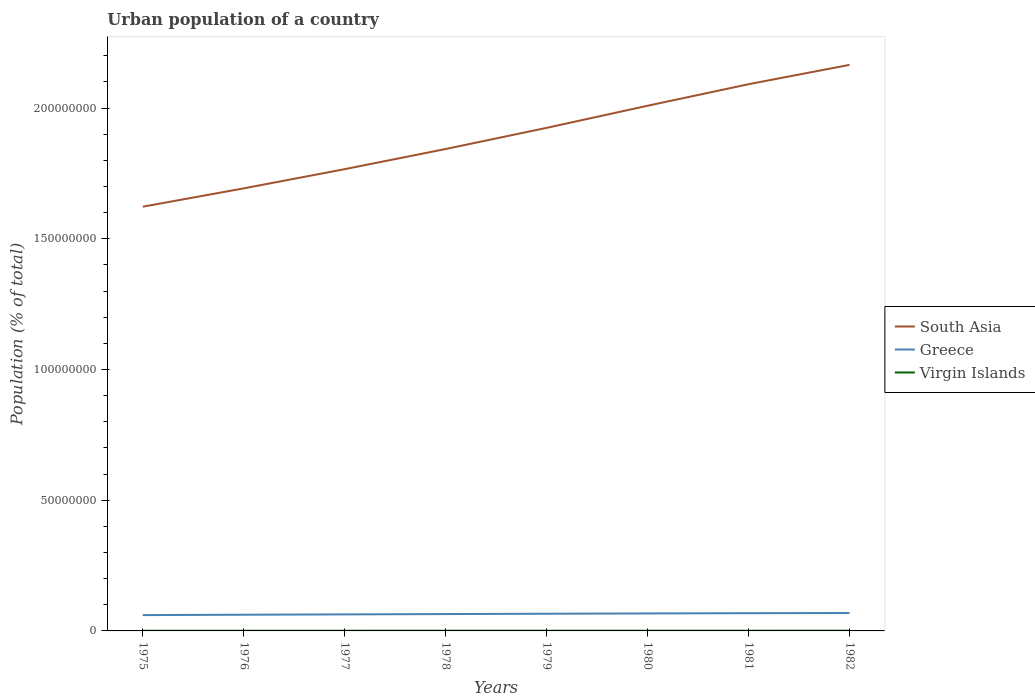Is the number of lines equal to the number of legend labels?
Your answer should be very brief. Yes. Across all years, what is the maximum urban population in South Asia?
Keep it short and to the point. 1.62e+08. In which year was the urban population in South Asia maximum?
Offer a very short reply. 1975. What is the total urban population in South Asia in the graph?
Offer a terse response. -3.99e+07. What is the difference between the highest and the second highest urban population in South Asia?
Offer a terse response. 5.42e+07. What is the difference between the highest and the lowest urban population in South Asia?
Give a very brief answer. 4. How many years are there in the graph?
Your response must be concise. 8. Are the values on the major ticks of Y-axis written in scientific E-notation?
Your answer should be compact. No. Does the graph contain grids?
Your answer should be compact. No. How are the legend labels stacked?
Offer a very short reply. Vertical. What is the title of the graph?
Keep it short and to the point. Urban population of a country. Does "Maldives" appear as one of the legend labels in the graph?
Your answer should be very brief. No. What is the label or title of the X-axis?
Offer a very short reply. Years. What is the label or title of the Y-axis?
Offer a terse response. Population (% of total). What is the Population (% of total) of South Asia in 1975?
Your answer should be very brief. 1.62e+08. What is the Population (% of total) in Greece in 1975?
Offer a very short reply. 6.06e+06. What is the Population (% of total) of Virgin Islands in 1975?
Your answer should be compact. 7.07e+04. What is the Population (% of total) of South Asia in 1976?
Make the answer very short. 1.69e+08. What is the Population (% of total) of Greece in 1976?
Your response must be concise. 6.20e+06. What is the Population (% of total) in Virgin Islands in 1976?
Offer a terse response. 7.32e+04. What is the Population (% of total) of South Asia in 1977?
Ensure brevity in your answer.  1.77e+08. What is the Population (% of total) in Greece in 1977?
Make the answer very short. 6.32e+06. What is the Population (% of total) in Virgin Islands in 1977?
Offer a terse response. 7.19e+04. What is the Population (% of total) of South Asia in 1978?
Your answer should be very brief. 1.84e+08. What is the Population (% of total) in Greece in 1978?
Give a very brief answer. 6.45e+06. What is the Population (% of total) in Virgin Islands in 1978?
Keep it short and to the point. 7.51e+04. What is the Population (% of total) in South Asia in 1979?
Provide a succinct answer. 1.92e+08. What is the Population (% of total) in Greece in 1979?
Your answer should be very brief. 6.58e+06. What is the Population (% of total) in Virgin Islands in 1979?
Offer a terse response. 7.61e+04. What is the Population (% of total) in South Asia in 1980?
Your response must be concise. 2.01e+08. What is the Population (% of total) of Greece in 1980?
Make the answer very short. 6.69e+06. What is the Population (% of total) in Virgin Islands in 1980?
Keep it short and to the point. 7.77e+04. What is the Population (% of total) in South Asia in 1981?
Provide a succinct answer. 2.09e+08. What is the Population (% of total) in Greece in 1981?
Offer a terse response. 6.79e+06. What is the Population (% of total) in Virgin Islands in 1981?
Give a very brief answer. 7.94e+04. What is the Population (% of total) in South Asia in 1982?
Your answer should be compact. 2.16e+08. What is the Population (% of total) of Greece in 1982?
Your response must be concise. 6.85e+06. What is the Population (% of total) in Virgin Islands in 1982?
Ensure brevity in your answer.  8.35e+04. Across all years, what is the maximum Population (% of total) of South Asia?
Your answer should be compact. 2.16e+08. Across all years, what is the maximum Population (% of total) in Greece?
Keep it short and to the point. 6.85e+06. Across all years, what is the maximum Population (% of total) of Virgin Islands?
Offer a very short reply. 8.35e+04. Across all years, what is the minimum Population (% of total) of South Asia?
Your response must be concise. 1.62e+08. Across all years, what is the minimum Population (% of total) of Greece?
Provide a succinct answer. 6.06e+06. Across all years, what is the minimum Population (% of total) in Virgin Islands?
Ensure brevity in your answer.  7.07e+04. What is the total Population (% of total) of South Asia in the graph?
Give a very brief answer. 1.51e+09. What is the total Population (% of total) in Greece in the graph?
Provide a succinct answer. 5.19e+07. What is the total Population (% of total) of Virgin Islands in the graph?
Keep it short and to the point. 6.08e+05. What is the difference between the Population (% of total) of South Asia in 1975 and that in 1976?
Your answer should be very brief. -7.01e+06. What is the difference between the Population (% of total) of Greece in 1975 and that in 1976?
Make the answer very short. -1.40e+05. What is the difference between the Population (% of total) in Virgin Islands in 1975 and that in 1976?
Ensure brevity in your answer.  -2506. What is the difference between the Population (% of total) in South Asia in 1975 and that in 1977?
Offer a very short reply. -1.44e+07. What is the difference between the Population (% of total) in Greece in 1975 and that in 1977?
Your answer should be very brief. -2.66e+05. What is the difference between the Population (% of total) in Virgin Islands in 1975 and that in 1977?
Ensure brevity in your answer.  -1157. What is the difference between the Population (% of total) in South Asia in 1975 and that in 1978?
Offer a very short reply. -2.21e+07. What is the difference between the Population (% of total) of Greece in 1975 and that in 1978?
Provide a short and direct response. -3.94e+05. What is the difference between the Population (% of total) in Virgin Islands in 1975 and that in 1978?
Your response must be concise. -4417. What is the difference between the Population (% of total) of South Asia in 1975 and that in 1979?
Offer a terse response. -3.02e+07. What is the difference between the Population (% of total) of Greece in 1975 and that in 1979?
Keep it short and to the point. -5.20e+05. What is the difference between the Population (% of total) in Virgin Islands in 1975 and that in 1979?
Make the answer very short. -5329. What is the difference between the Population (% of total) in South Asia in 1975 and that in 1980?
Your response must be concise. -3.86e+07. What is the difference between the Population (% of total) in Greece in 1975 and that in 1980?
Your answer should be very brief. -6.31e+05. What is the difference between the Population (% of total) in Virgin Islands in 1975 and that in 1980?
Ensure brevity in your answer.  -7013. What is the difference between the Population (% of total) in South Asia in 1975 and that in 1981?
Provide a succinct answer. -4.68e+07. What is the difference between the Population (% of total) in Greece in 1975 and that in 1981?
Your answer should be very brief. -7.30e+05. What is the difference between the Population (% of total) of Virgin Islands in 1975 and that in 1981?
Your answer should be very brief. -8683. What is the difference between the Population (% of total) in South Asia in 1975 and that in 1982?
Offer a very short reply. -5.42e+07. What is the difference between the Population (% of total) in Greece in 1975 and that in 1982?
Give a very brief answer. -7.91e+05. What is the difference between the Population (% of total) in Virgin Islands in 1975 and that in 1982?
Your answer should be very brief. -1.28e+04. What is the difference between the Population (% of total) in South Asia in 1976 and that in 1977?
Offer a very short reply. -7.35e+06. What is the difference between the Population (% of total) in Greece in 1976 and that in 1977?
Offer a very short reply. -1.26e+05. What is the difference between the Population (% of total) in Virgin Islands in 1976 and that in 1977?
Offer a very short reply. 1349. What is the difference between the Population (% of total) of South Asia in 1976 and that in 1978?
Provide a short and direct response. -1.51e+07. What is the difference between the Population (% of total) in Greece in 1976 and that in 1978?
Provide a succinct answer. -2.54e+05. What is the difference between the Population (% of total) of Virgin Islands in 1976 and that in 1978?
Provide a short and direct response. -1911. What is the difference between the Population (% of total) of South Asia in 1976 and that in 1979?
Provide a succinct answer. -2.31e+07. What is the difference between the Population (% of total) of Greece in 1976 and that in 1979?
Make the answer very short. -3.80e+05. What is the difference between the Population (% of total) in Virgin Islands in 1976 and that in 1979?
Provide a succinct answer. -2823. What is the difference between the Population (% of total) of South Asia in 1976 and that in 1980?
Offer a very short reply. -3.16e+07. What is the difference between the Population (% of total) in Greece in 1976 and that in 1980?
Keep it short and to the point. -4.91e+05. What is the difference between the Population (% of total) in Virgin Islands in 1976 and that in 1980?
Provide a succinct answer. -4507. What is the difference between the Population (% of total) in South Asia in 1976 and that in 1981?
Your answer should be very brief. -3.98e+07. What is the difference between the Population (% of total) of Greece in 1976 and that in 1981?
Provide a short and direct response. -5.90e+05. What is the difference between the Population (% of total) in Virgin Islands in 1976 and that in 1981?
Make the answer very short. -6177. What is the difference between the Population (% of total) in South Asia in 1976 and that in 1982?
Ensure brevity in your answer.  -4.72e+07. What is the difference between the Population (% of total) in Greece in 1976 and that in 1982?
Your response must be concise. -6.51e+05. What is the difference between the Population (% of total) in Virgin Islands in 1976 and that in 1982?
Your answer should be compact. -1.03e+04. What is the difference between the Population (% of total) in South Asia in 1977 and that in 1978?
Provide a succinct answer. -7.71e+06. What is the difference between the Population (% of total) of Greece in 1977 and that in 1978?
Provide a succinct answer. -1.28e+05. What is the difference between the Population (% of total) in Virgin Islands in 1977 and that in 1978?
Keep it short and to the point. -3260. What is the difference between the Population (% of total) of South Asia in 1977 and that in 1979?
Provide a succinct answer. -1.58e+07. What is the difference between the Population (% of total) in Greece in 1977 and that in 1979?
Provide a succinct answer. -2.54e+05. What is the difference between the Population (% of total) of Virgin Islands in 1977 and that in 1979?
Make the answer very short. -4172. What is the difference between the Population (% of total) in South Asia in 1977 and that in 1980?
Offer a terse response. -2.43e+07. What is the difference between the Population (% of total) in Greece in 1977 and that in 1980?
Offer a terse response. -3.65e+05. What is the difference between the Population (% of total) in Virgin Islands in 1977 and that in 1980?
Offer a terse response. -5856. What is the difference between the Population (% of total) of South Asia in 1977 and that in 1981?
Your answer should be very brief. -3.25e+07. What is the difference between the Population (% of total) in Greece in 1977 and that in 1981?
Your answer should be compact. -4.64e+05. What is the difference between the Population (% of total) of Virgin Islands in 1977 and that in 1981?
Your answer should be compact. -7526. What is the difference between the Population (% of total) of South Asia in 1977 and that in 1982?
Offer a very short reply. -3.99e+07. What is the difference between the Population (% of total) in Greece in 1977 and that in 1982?
Your answer should be compact. -5.25e+05. What is the difference between the Population (% of total) of Virgin Islands in 1977 and that in 1982?
Your answer should be very brief. -1.16e+04. What is the difference between the Population (% of total) of South Asia in 1978 and that in 1979?
Ensure brevity in your answer.  -8.09e+06. What is the difference between the Population (% of total) of Greece in 1978 and that in 1979?
Your answer should be compact. -1.26e+05. What is the difference between the Population (% of total) in Virgin Islands in 1978 and that in 1979?
Ensure brevity in your answer.  -912. What is the difference between the Population (% of total) of South Asia in 1978 and that in 1980?
Ensure brevity in your answer.  -1.65e+07. What is the difference between the Population (% of total) in Greece in 1978 and that in 1980?
Keep it short and to the point. -2.37e+05. What is the difference between the Population (% of total) in Virgin Islands in 1978 and that in 1980?
Provide a succinct answer. -2596. What is the difference between the Population (% of total) of South Asia in 1978 and that in 1981?
Your answer should be compact. -2.48e+07. What is the difference between the Population (% of total) in Greece in 1978 and that in 1981?
Provide a short and direct response. -3.36e+05. What is the difference between the Population (% of total) of Virgin Islands in 1978 and that in 1981?
Keep it short and to the point. -4266. What is the difference between the Population (% of total) of South Asia in 1978 and that in 1982?
Your answer should be compact. -3.22e+07. What is the difference between the Population (% of total) of Greece in 1978 and that in 1982?
Offer a terse response. -3.97e+05. What is the difference between the Population (% of total) of Virgin Islands in 1978 and that in 1982?
Offer a terse response. -8382. What is the difference between the Population (% of total) in South Asia in 1979 and that in 1980?
Keep it short and to the point. -8.46e+06. What is the difference between the Population (% of total) in Greece in 1979 and that in 1980?
Your answer should be very brief. -1.11e+05. What is the difference between the Population (% of total) of Virgin Islands in 1979 and that in 1980?
Offer a very short reply. -1684. What is the difference between the Population (% of total) of South Asia in 1979 and that in 1981?
Make the answer very short. -1.67e+07. What is the difference between the Population (% of total) of Greece in 1979 and that in 1981?
Offer a terse response. -2.10e+05. What is the difference between the Population (% of total) of Virgin Islands in 1979 and that in 1981?
Your answer should be very brief. -3354. What is the difference between the Population (% of total) of South Asia in 1979 and that in 1982?
Offer a terse response. -2.41e+07. What is the difference between the Population (% of total) of Greece in 1979 and that in 1982?
Provide a short and direct response. -2.71e+05. What is the difference between the Population (% of total) in Virgin Islands in 1979 and that in 1982?
Provide a short and direct response. -7470. What is the difference between the Population (% of total) of South Asia in 1980 and that in 1981?
Keep it short and to the point. -8.24e+06. What is the difference between the Population (% of total) of Greece in 1980 and that in 1981?
Make the answer very short. -9.94e+04. What is the difference between the Population (% of total) of Virgin Islands in 1980 and that in 1981?
Provide a succinct answer. -1670. What is the difference between the Population (% of total) of South Asia in 1980 and that in 1982?
Make the answer very short. -1.56e+07. What is the difference between the Population (% of total) of Greece in 1980 and that in 1982?
Offer a terse response. -1.60e+05. What is the difference between the Population (% of total) in Virgin Islands in 1980 and that in 1982?
Make the answer very short. -5786. What is the difference between the Population (% of total) in South Asia in 1981 and that in 1982?
Your response must be concise. -7.40e+06. What is the difference between the Population (% of total) in Greece in 1981 and that in 1982?
Your answer should be very brief. -6.10e+04. What is the difference between the Population (% of total) of Virgin Islands in 1981 and that in 1982?
Your answer should be compact. -4116. What is the difference between the Population (% of total) of South Asia in 1975 and the Population (% of total) of Greece in 1976?
Provide a short and direct response. 1.56e+08. What is the difference between the Population (% of total) of South Asia in 1975 and the Population (% of total) of Virgin Islands in 1976?
Give a very brief answer. 1.62e+08. What is the difference between the Population (% of total) in Greece in 1975 and the Population (% of total) in Virgin Islands in 1976?
Make the answer very short. 5.98e+06. What is the difference between the Population (% of total) in South Asia in 1975 and the Population (% of total) in Greece in 1977?
Keep it short and to the point. 1.56e+08. What is the difference between the Population (% of total) in South Asia in 1975 and the Population (% of total) in Virgin Islands in 1977?
Your response must be concise. 1.62e+08. What is the difference between the Population (% of total) in Greece in 1975 and the Population (% of total) in Virgin Islands in 1977?
Give a very brief answer. 5.98e+06. What is the difference between the Population (% of total) of South Asia in 1975 and the Population (% of total) of Greece in 1978?
Your answer should be compact. 1.56e+08. What is the difference between the Population (% of total) of South Asia in 1975 and the Population (% of total) of Virgin Islands in 1978?
Your answer should be very brief. 1.62e+08. What is the difference between the Population (% of total) of Greece in 1975 and the Population (% of total) of Virgin Islands in 1978?
Make the answer very short. 5.98e+06. What is the difference between the Population (% of total) in South Asia in 1975 and the Population (% of total) in Greece in 1979?
Provide a succinct answer. 1.56e+08. What is the difference between the Population (% of total) in South Asia in 1975 and the Population (% of total) in Virgin Islands in 1979?
Give a very brief answer. 1.62e+08. What is the difference between the Population (% of total) of Greece in 1975 and the Population (% of total) of Virgin Islands in 1979?
Make the answer very short. 5.98e+06. What is the difference between the Population (% of total) in South Asia in 1975 and the Population (% of total) in Greece in 1980?
Provide a short and direct response. 1.56e+08. What is the difference between the Population (% of total) in South Asia in 1975 and the Population (% of total) in Virgin Islands in 1980?
Your answer should be compact. 1.62e+08. What is the difference between the Population (% of total) of Greece in 1975 and the Population (% of total) of Virgin Islands in 1980?
Keep it short and to the point. 5.98e+06. What is the difference between the Population (% of total) in South Asia in 1975 and the Population (% of total) in Greece in 1981?
Give a very brief answer. 1.55e+08. What is the difference between the Population (% of total) in South Asia in 1975 and the Population (% of total) in Virgin Islands in 1981?
Make the answer very short. 1.62e+08. What is the difference between the Population (% of total) of Greece in 1975 and the Population (% of total) of Virgin Islands in 1981?
Give a very brief answer. 5.98e+06. What is the difference between the Population (% of total) of South Asia in 1975 and the Population (% of total) of Greece in 1982?
Offer a very short reply. 1.55e+08. What is the difference between the Population (% of total) in South Asia in 1975 and the Population (% of total) in Virgin Islands in 1982?
Give a very brief answer. 1.62e+08. What is the difference between the Population (% of total) in Greece in 1975 and the Population (% of total) in Virgin Islands in 1982?
Your answer should be very brief. 5.97e+06. What is the difference between the Population (% of total) in South Asia in 1976 and the Population (% of total) in Greece in 1977?
Provide a succinct answer. 1.63e+08. What is the difference between the Population (% of total) in South Asia in 1976 and the Population (% of total) in Virgin Islands in 1977?
Ensure brevity in your answer.  1.69e+08. What is the difference between the Population (% of total) of Greece in 1976 and the Population (% of total) of Virgin Islands in 1977?
Offer a very short reply. 6.12e+06. What is the difference between the Population (% of total) in South Asia in 1976 and the Population (% of total) in Greece in 1978?
Make the answer very short. 1.63e+08. What is the difference between the Population (% of total) in South Asia in 1976 and the Population (% of total) in Virgin Islands in 1978?
Give a very brief answer. 1.69e+08. What is the difference between the Population (% of total) of Greece in 1976 and the Population (% of total) of Virgin Islands in 1978?
Ensure brevity in your answer.  6.12e+06. What is the difference between the Population (% of total) of South Asia in 1976 and the Population (% of total) of Greece in 1979?
Offer a terse response. 1.63e+08. What is the difference between the Population (% of total) in South Asia in 1976 and the Population (% of total) in Virgin Islands in 1979?
Offer a terse response. 1.69e+08. What is the difference between the Population (% of total) of Greece in 1976 and the Population (% of total) of Virgin Islands in 1979?
Offer a terse response. 6.12e+06. What is the difference between the Population (% of total) in South Asia in 1976 and the Population (% of total) in Greece in 1980?
Give a very brief answer. 1.63e+08. What is the difference between the Population (% of total) of South Asia in 1976 and the Population (% of total) of Virgin Islands in 1980?
Keep it short and to the point. 1.69e+08. What is the difference between the Population (% of total) in Greece in 1976 and the Population (% of total) in Virgin Islands in 1980?
Provide a short and direct response. 6.12e+06. What is the difference between the Population (% of total) in South Asia in 1976 and the Population (% of total) in Greece in 1981?
Provide a succinct answer. 1.62e+08. What is the difference between the Population (% of total) in South Asia in 1976 and the Population (% of total) in Virgin Islands in 1981?
Make the answer very short. 1.69e+08. What is the difference between the Population (% of total) of Greece in 1976 and the Population (% of total) of Virgin Islands in 1981?
Offer a very short reply. 6.12e+06. What is the difference between the Population (% of total) of South Asia in 1976 and the Population (% of total) of Greece in 1982?
Provide a short and direct response. 1.62e+08. What is the difference between the Population (% of total) in South Asia in 1976 and the Population (% of total) in Virgin Islands in 1982?
Your response must be concise. 1.69e+08. What is the difference between the Population (% of total) of Greece in 1976 and the Population (% of total) of Virgin Islands in 1982?
Offer a terse response. 6.11e+06. What is the difference between the Population (% of total) in South Asia in 1977 and the Population (% of total) in Greece in 1978?
Make the answer very short. 1.70e+08. What is the difference between the Population (% of total) in South Asia in 1977 and the Population (% of total) in Virgin Islands in 1978?
Keep it short and to the point. 1.77e+08. What is the difference between the Population (% of total) of Greece in 1977 and the Population (% of total) of Virgin Islands in 1978?
Provide a short and direct response. 6.25e+06. What is the difference between the Population (% of total) in South Asia in 1977 and the Population (% of total) in Greece in 1979?
Give a very brief answer. 1.70e+08. What is the difference between the Population (% of total) in South Asia in 1977 and the Population (% of total) in Virgin Islands in 1979?
Your answer should be very brief. 1.77e+08. What is the difference between the Population (% of total) in Greece in 1977 and the Population (% of total) in Virgin Islands in 1979?
Your response must be concise. 6.25e+06. What is the difference between the Population (% of total) in South Asia in 1977 and the Population (% of total) in Greece in 1980?
Give a very brief answer. 1.70e+08. What is the difference between the Population (% of total) of South Asia in 1977 and the Population (% of total) of Virgin Islands in 1980?
Offer a terse response. 1.77e+08. What is the difference between the Population (% of total) of Greece in 1977 and the Population (% of total) of Virgin Islands in 1980?
Offer a very short reply. 6.24e+06. What is the difference between the Population (% of total) of South Asia in 1977 and the Population (% of total) of Greece in 1981?
Keep it short and to the point. 1.70e+08. What is the difference between the Population (% of total) in South Asia in 1977 and the Population (% of total) in Virgin Islands in 1981?
Provide a short and direct response. 1.77e+08. What is the difference between the Population (% of total) in Greece in 1977 and the Population (% of total) in Virgin Islands in 1981?
Provide a succinct answer. 6.24e+06. What is the difference between the Population (% of total) of South Asia in 1977 and the Population (% of total) of Greece in 1982?
Provide a short and direct response. 1.70e+08. What is the difference between the Population (% of total) in South Asia in 1977 and the Population (% of total) in Virgin Islands in 1982?
Provide a short and direct response. 1.77e+08. What is the difference between the Population (% of total) in Greece in 1977 and the Population (% of total) in Virgin Islands in 1982?
Ensure brevity in your answer.  6.24e+06. What is the difference between the Population (% of total) of South Asia in 1978 and the Population (% of total) of Greece in 1979?
Keep it short and to the point. 1.78e+08. What is the difference between the Population (% of total) of South Asia in 1978 and the Population (% of total) of Virgin Islands in 1979?
Keep it short and to the point. 1.84e+08. What is the difference between the Population (% of total) in Greece in 1978 and the Population (% of total) in Virgin Islands in 1979?
Make the answer very short. 6.37e+06. What is the difference between the Population (% of total) in South Asia in 1978 and the Population (% of total) in Greece in 1980?
Make the answer very short. 1.78e+08. What is the difference between the Population (% of total) of South Asia in 1978 and the Population (% of total) of Virgin Islands in 1980?
Provide a succinct answer. 1.84e+08. What is the difference between the Population (% of total) in Greece in 1978 and the Population (% of total) in Virgin Islands in 1980?
Make the answer very short. 6.37e+06. What is the difference between the Population (% of total) in South Asia in 1978 and the Population (% of total) in Greece in 1981?
Keep it short and to the point. 1.78e+08. What is the difference between the Population (% of total) of South Asia in 1978 and the Population (% of total) of Virgin Islands in 1981?
Offer a very short reply. 1.84e+08. What is the difference between the Population (% of total) in Greece in 1978 and the Population (% of total) in Virgin Islands in 1981?
Offer a very short reply. 6.37e+06. What is the difference between the Population (% of total) in South Asia in 1978 and the Population (% of total) in Greece in 1982?
Make the answer very short. 1.77e+08. What is the difference between the Population (% of total) in South Asia in 1978 and the Population (% of total) in Virgin Islands in 1982?
Your answer should be compact. 1.84e+08. What is the difference between the Population (% of total) in Greece in 1978 and the Population (% of total) in Virgin Islands in 1982?
Give a very brief answer. 6.37e+06. What is the difference between the Population (% of total) of South Asia in 1979 and the Population (% of total) of Greece in 1980?
Offer a terse response. 1.86e+08. What is the difference between the Population (% of total) of South Asia in 1979 and the Population (% of total) of Virgin Islands in 1980?
Make the answer very short. 1.92e+08. What is the difference between the Population (% of total) of Greece in 1979 and the Population (% of total) of Virgin Islands in 1980?
Provide a succinct answer. 6.50e+06. What is the difference between the Population (% of total) of South Asia in 1979 and the Population (% of total) of Greece in 1981?
Offer a very short reply. 1.86e+08. What is the difference between the Population (% of total) in South Asia in 1979 and the Population (% of total) in Virgin Islands in 1981?
Provide a succinct answer. 1.92e+08. What is the difference between the Population (% of total) in Greece in 1979 and the Population (% of total) in Virgin Islands in 1981?
Offer a very short reply. 6.50e+06. What is the difference between the Population (% of total) of South Asia in 1979 and the Population (% of total) of Greece in 1982?
Your answer should be compact. 1.86e+08. What is the difference between the Population (% of total) of South Asia in 1979 and the Population (% of total) of Virgin Islands in 1982?
Your answer should be very brief. 1.92e+08. What is the difference between the Population (% of total) of Greece in 1979 and the Population (% of total) of Virgin Islands in 1982?
Your answer should be very brief. 6.49e+06. What is the difference between the Population (% of total) of South Asia in 1980 and the Population (% of total) of Greece in 1981?
Your response must be concise. 1.94e+08. What is the difference between the Population (% of total) in South Asia in 1980 and the Population (% of total) in Virgin Islands in 1981?
Offer a very short reply. 2.01e+08. What is the difference between the Population (% of total) in Greece in 1980 and the Population (% of total) in Virgin Islands in 1981?
Provide a short and direct response. 6.61e+06. What is the difference between the Population (% of total) of South Asia in 1980 and the Population (% of total) of Greece in 1982?
Give a very brief answer. 1.94e+08. What is the difference between the Population (% of total) in South Asia in 1980 and the Population (% of total) in Virgin Islands in 1982?
Offer a very short reply. 2.01e+08. What is the difference between the Population (% of total) in Greece in 1980 and the Population (% of total) in Virgin Islands in 1982?
Offer a very short reply. 6.60e+06. What is the difference between the Population (% of total) in South Asia in 1981 and the Population (% of total) in Greece in 1982?
Make the answer very short. 2.02e+08. What is the difference between the Population (% of total) in South Asia in 1981 and the Population (% of total) in Virgin Islands in 1982?
Your answer should be very brief. 2.09e+08. What is the difference between the Population (% of total) of Greece in 1981 and the Population (% of total) of Virgin Islands in 1982?
Keep it short and to the point. 6.70e+06. What is the average Population (% of total) in South Asia per year?
Your answer should be very brief. 1.89e+08. What is the average Population (% of total) in Greece per year?
Your answer should be very brief. 6.49e+06. What is the average Population (% of total) of Virgin Islands per year?
Keep it short and to the point. 7.60e+04. In the year 1975, what is the difference between the Population (% of total) of South Asia and Population (% of total) of Greece?
Offer a terse response. 1.56e+08. In the year 1975, what is the difference between the Population (% of total) of South Asia and Population (% of total) of Virgin Islands?
Make the answer very short. 1.62e+08. In the year 1975, what is the difference between the Population (% of total) of Greece and Population (% of total) of Virgin Islands?
Make the answer very short. 5.99e+06. In the year 1976, what is the difference between the Population (% of total) of South Asia and Population (% of total) of Greece?
Make the answer very short. 1.63e+08. In the year 1976, what is the difference between the Population (% of total) in South Asia and Population (% of total) in Virgin Islands?
Your answer should be very brief. 1.69e+08. In the year 1976, what is the difference between the Population (% of total) of Greece and Population (% of total) of Virgin Islands?
Your answer should be very brief. 6.12e+06. In the year 1977, what is the difference between the Population (% of total) in South Asia and Population (% of total) in Greece?
Offer a terse response. 1.70e+08. In the year 1977, what is the difference between the Population (% of total) in South Asia and Population (% of total) in Virgin Islands?
Ensure brevity in your answer.  1.77e+08. In the year 1977, what is the difference between the Population (% of total) in Greece and Population (% of total) in Virgin Islands?
Your answer should be compact. 6.25e+06. In the year 1978, what is the difference between the Population (% of total) of South Asia and Population (% of total) of Greece?
Ensure brevity in your answer.  1.78e+08. In the year 1978, what is the difference between the Population (% of total) of South Asia and Population (% of total) of Virgin Islands?
Offer a terse response. 1.84e+08. In the year 1978, what is the difference between the Population (% of total) in Greece and Population (% of total) in Virgin Islands?
Offer a terse response. 6.37e+06. In the year 1979, what is the difference between the Population (% of total) of South Asia and Population (% of total) of Greece?
Provide a succinct answer. 1.86e+08. In the year 1979, what is the difference between the Population (% of total) in South Asia and Population (% of total) in Virgin Islands?
Your response must be concise. 1.92e+08. In the year 1979, what is the difference between the Population (% of total) of Greece and Population (% of total) of Virgin Islands?
Give a very brief answer. 6.50e+06. In the year 1980, what is the difference between the Population (% of total) in South Asia and Population (% of total) in Greece?
Provide a succinct answer. 1.94e+08. In the year 1980, what is the difference between the Population (% of total) of South Asia and Population (% of total) of Virgin Islands?
Make the answer very short. 2.01e+08. In the year 1980, what is the difference between the Population (% of total) of Greece and Population (% of total) of Virgin Islands?
Your answer should be compact. 6.61e+06. In the year 1981, what is the difference between the Population (% of total) of South Asia and Population (% of total) of Greece?
Make the answer very short. 2.02e+08. In the year 1981, what is the difference between the Population (% of total) of South Asia and Population (% of total) of Virgin Islands?
Your answer should be very brief. 2.09e+08. In the year 1981, what is the difference between the Population (% of total) of Greece and Population (% of total) of Virgin Islands?
Offer a very short reply. 6.71e+06. In the year 1982, what is the difference between the Population (% of total) in South Asia and Population (% of total) in Greece?
Give a very brief answer. 2.10e+08. In the year 1982, what is the difference between the Population (% of total) in South Asia and Population (% of total) in Virgin Islands?
Provide a short and direct response. 2.16e+08. In the year 1982, what is the difference between the Population (% of total) in Greece and Population (% of total) in Virgin Islands?
Offer a very short reply. 6.76e+06. What is the ratio of the Population (% of total) of South Asia in 1975 to that in 1976?
Make the answer very short. 0.96. What is the ratio of the Population (% of total) in Greece in 1975 to that in 1976?
Provide a succinct answer. 0.98. What is the ratio of the Population (% of total) of Virgin Islands in 1975 to that in 1976?
Give a very brief answer. 0.97. What is the ratio of the Population (% of total) in South Asia in 1975 to that in 1977?
Your answer should be very brief. 0.92. What is the ratio of the Population (% of total) of Greece in 1975 to that in 1977?
Ensure brevity in your answer.  0.96. What is the ratio of the Population (% of total) in Virgin Islands in 1975 to that in 1977?
Ensure brevity in your answer.  0.98. What is the ratio of the Population (% of total) in South Asia in 1975 to that in 1978?
Give a very brief answer. 0.88. What is the ratio of the Population (% of total) in Greece in 1975 to that in 1978?
Offer a very short reply. 0.94. What is the ratio of the Population (% of total) in Virgin Islands in 1975 to that in 1978?
Ensure brevity in your answer.  0.94. What is the ratio of the Population (% of total) in South Asia in 1975 to that in 1979?
Your answer should be compact. 0.84. What is the ratio of the Population (% of total) in Greece in 1975 to that in 1979?
Provide a succinct answer. 0.92. What is the ratio of the Population (% of total) in Virgin Islands in 1975 to that in 1979?
Provide a succinct answer. 0.93. What is the ratio of the Population (% of total) of South Asia in 1975 to that in 1980?
Provide a succinct answer. 0.81. What is the ratio of the Population (% of total) of Greece in 1975 to that in 1980?
Provide a short and direct response. 0.91. What is the ratio of the Population (% of total) of Virgin Islands in 1975 to that in 1980?
Give a very brief answer. 0.91. What is the ratio of the Population (% of total) of South Asia in 1975 to that in 1981?
Make the answer very short. 0.78. What is the ratio of the Population (% of total) in Greece in 1975 to that in 1981?
Give a very brief answer. 0.89. What is the ratio of the Population (% of total) in Virgin Islands in 1975 to that in 1981?
Give a very brief answer. 0.89. What is the ratio of the Population (% of total) of South Asia in 1975 to that in 1982?
Your response must be concise. 0.75. What is the ratio of the Population (% of total) of Greece in 1975 to that in 1982?
Provide a succinct answer. 0.88. What is the ratio of the Population (% of total) in Virgin Islands in 1975 to that in 1982?
Ensure brevity in your answer.  0.85. What is the ratio of the Population (% of total) of South Asia in 1976 to that in 1977?
Make the answer very short. 0.96. What is the ratio of the Population (% of total) of Greece in 1976 to that in 1977?
Your response must be concise. 0.98. What is the ratio of the Population (% of total) in Virgin Islands in 1976 to that in 1977?
Your answer should be compact. 1.02. What is the ratio of the Population (% of total) in South Asia in 1976 to that in 1978?
Your answer should be very brief. 0.92. What is the ratio of the Population (% of total) in Greece in 1976 to that in 1978?
Keep it short and to the point. 0.96. What is the ratio of the Population (% of total) of Virgin Islands in 1976 to that in 1978?
Your response must be concise. 0.97. What is the ratio of the Population (% of total) in South Asia in 1976 to that in 1979?
Ensure brevity in your answer.  0.88. What is the ratio of the Population (% of total) of Greece in 1976 to that in 1979?
Make the answer very short. 0.94. What is the ratio of the Population (% of total) in Virgin Islands in 1976 to that in 1979?
Your answer should be compact. 0.96. What is the ratio of the Population (% of total) of South Asia in 1976 to that in 1980?
Ensure brevity in your answer.  0.84. What is the ratio of the Population (% of total) of Greece in 1976 to that in 1980?
Provide a short and direct response. 0.93. What is the ratio of the Population (% of total) in Virgin Islands in 1976 to that in 1980?
Provide a short and direct response. 0.94. What is the ratio of the Population (% of total) of South Asia in 1976 to that in 1981?
Make the answer very short. 0.81. What is the ratio of the Population (% of total) of Greece in 1976 to that in 1981?
Provide a succinct answer. 0.91. What is the ratio of the Population (% of total) in Virgin Islands in 1976 to that in 1981?
Your response must be concise. 0.92. What is the ratio of the Population (% of total) of South Asia in 1976 to that in 1982?
Offer a terse response. 0.78. What is the ratio of the Population (% of total) of Greece in 1976 to that in 1982?
Your answer should be very brief. 0.9. What is the ratio of the Population (% of total) of Virgin Islands in 1976 to that in 1982?
Make the answer very short. 0.88. What is the ratio of the Population (% of total) of South Asia in 1977 to that in 1978?
Your answer should be very brief. 0.96. What is the ratio of the Population (% of total) in Greece in 1977 to that in 1978?
Your answer should be compact. 0.98. What is the ratio of the Population (% of total) of Virgin Islands in 1977 to that in 1978?
Give a very brief answer. 0.96. What is the ratio of the Population (% of total) in South Asia in 1977 to that in 1979?
Your answer should be compact. 0.92. What is the ratio of the Population (% of total) of Greece in 1977 to that in 1979?
Your response must be concise. 0.96. What is the ratio of the Population (% of total) in Virgin Islands in 1977 to that in 1979?
Offer a terse response. 0.95. What is the ratio of the Population (% of total) in South Asia in 1977 to that in 1980?
Your response must be concise. 0.88. What is the ratio of the Population (% of total) in Greece in 1977 to that in 1980?
Your answer should be very brief. 0.95. What is the ratio of the Population (% of total) in Virgin Islands in 1977 to that in 1980?
Ensure brevity in your answer.  0.92. What is the ratio of the Population (% of total) of South Asia in 1977 to that in 1981?
Make the answer very short. 0.84. What is the ratio of the Population (% of total) of Greece in 1977 to that in 1981?
Keep it short and to the point. 0.93. What is the ratio of the Population (% of total) in Virgin Islands in 1977 to that in 1981?
Provide a succinct answer. 0.91. What is the ratio of the Population (% of total) in South Asia in 1977 to that in 1982?
Your answer should be very brief. 0.82. What is the ratio of the Population (% of total) in Greece in 1977 to that in 1982?
Offer a terse response. 0.92. What is the ratio of the Population (% of total) of Virgin Islands in 1977 to that in 1982?
Your answer should be very brief. 0.86. What is the ratio of the Population (% of total) in South Asia in 1978 to that in 1979?
Make the answer very short. 0.96. What is the ratio of the Population (% of total) of Greece in 1978 to that in 1979?
Provide a short and direct response. 0.98. What is the ratio of the Population (% of total) in South Asia in 1978 to that in 1980?
Your answer should be very brief. 0.92. What is the ratio of the Population (% of total) in Greece in 1978 to that in 1980?
Ensure brevity in your answer.  0.96. What is the ratio of the Population (% of total) of Virgin Islands in 1978 to that in 1980?
Give a very brief answer. 0.97. What is the ratio of the Population (% of total) in South Asia in 1978 to that in 1981?
Provide a succinct answer. 0.88. What is the ratio of the Population (% of total) of Greece in 1978 to that in 1981?
Your answer should be compact. 0.95. What is the ratio of the Population (% of total) in Virgin Islands in 1978 to that in 1981?
Ensure brevity in your answer.  0.95. What is the ratio of the Population (% of total) of South Asia in 1978 to that in 1982?
Give a very brief answer. 0.85. What is the ratio of the Population (% of total) of Greece in 1978 to that in 1982?
Give a very brief answer. 0.94. What is the ratio of the Population (% of total) in Virgin Islands in 1978 to that in 1982?
Your answer should be very brief. 0.9. What is the ratio of the Population (% of total) of South Asia in 1979 to that in 1980?
Offer a very short reply. 0.96. What is the ratio of the Population (% of total) of Greece in 1979 to that in 1980?
Keep it short and to the point. 0.98. What is the ratio of the Population (% of total) in Virgin Islands in 1979 to that in 1980?
Ensure brevity in your answer.  0.98. What is the ratio of the Population (% of total) in South Asia in 1979 to that in 1981?
Your answer should be compact. 0.92. What is the ratio of the Population (% of total) in Greece in 1979 to that in 1981?
Offer a terse response. 0.97. What is the ratio of the Population (% of total) of Virgin Islands in 1979 to that in 1981?
Keep it short and to the point. 0.96. What is the ratio of the Population (% of total) in South Asia in 1979 to that in 1982?
Provide a short and direct response. 0.89. What is the ratio of the Population (% of total) of Greece in 1979 to that in 1982?
Provide a short and direct response. 0.96. What is the ratio of the Population (% of total) of Virgin Islands in 1979 to that in 1982?
Offer a terse response. 0.91. What is the ratio of the Population (% of total) of South Asia in 1980 to that in 1981?
Give a very brief answer. 0.96. What is the ratio of the Population (% of total) of Virgin Islands in 1980 to that in 1981?
Offer a very short reply. 0.98. What is the ratio of the Population (% of total) of South Asia in 1980 to that in 1982?
Offer a very short reply. 0.93. What is the ratio of the Population (% of total) of Greece in 1980 to that in 1982?
Provide a succinct answer. 0.98. What is the ratio of the Population (% of total) in Virgin Islands in 1980 to that in 1982?
Give a very brief answer. 0.93. What is the ratio of the Population (% of total) in South Asia in 1981 to that in 1982?
Offer a terse response. 0.97. What is the ratio of the Population (% of total) of Greece in 1981 to that in 1982?
Give a very brief answer. 0.99. What is the ratio of the Population (% of total) in Virgin Islands in 1981 to that in 1982?
Offer a terse response. 0.95. What is the difference between the highest and the second highest Population (% of total) in South Asia?
Your response must be concise. 7.40e+06. What is the difference between the highest and the second highest Population (% of total) of Greece?
Offer a very short reply. 6.10e+04. What is the difference between the highest and the second highest Population (% of total) in Virgin Islands?
Make the answer very short. 4116. What is the difference between the highest and the lowest Population (% of total) of South Asia?
Make the answer very short. 5.42e+07. What is the difference between the highest and the lowest Population (% of total) in Greece?
Provide a short and direct response. 7.91e+05. What is the difference between the highest and the lowest Population (% of total) in Virgin Islands?
Your response must be concise. 1.28e+04. 